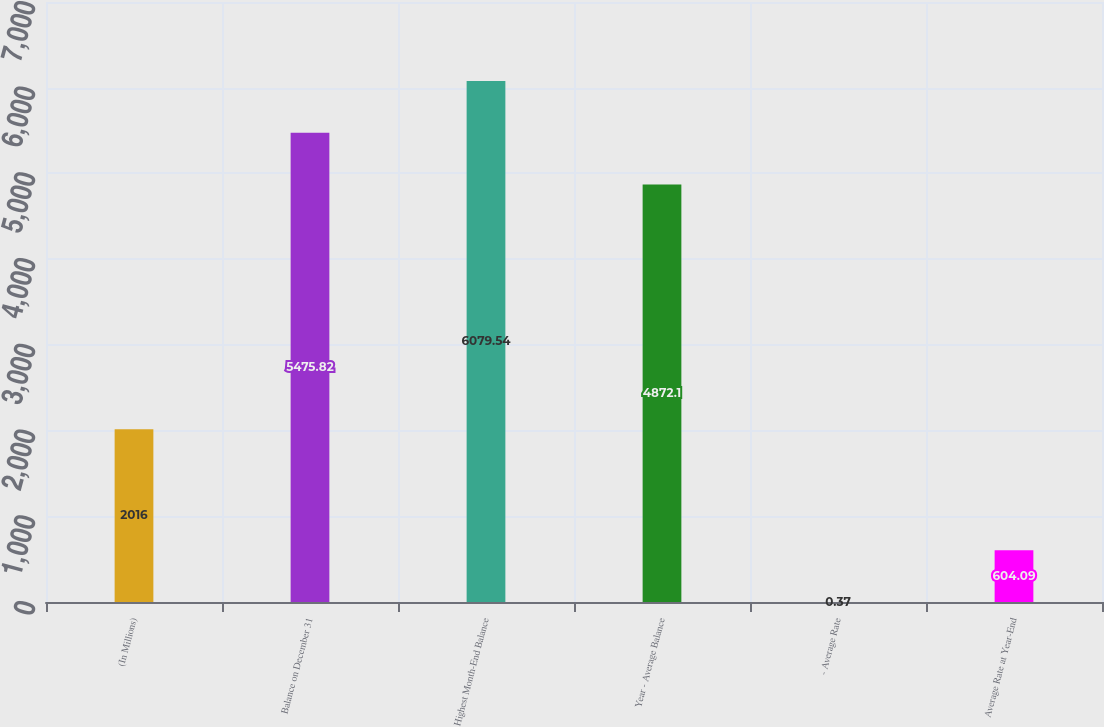Convert chart. <chart><loc_0><loc_0><loc_500><loc_500><bar_chart><fcel>(In Millions)<fcel>Balance on December 31<fcel>Highest Month-End Balance<fcel>Year - Average Balance<fcel>- Average Rate<fcel>Average Rate at Year-End<nl><fcel>2016<fcel>5475.82<fcel>6079.54<fcel>4872.1<fcel>0.37<fcel>604.09<nl></chart> 